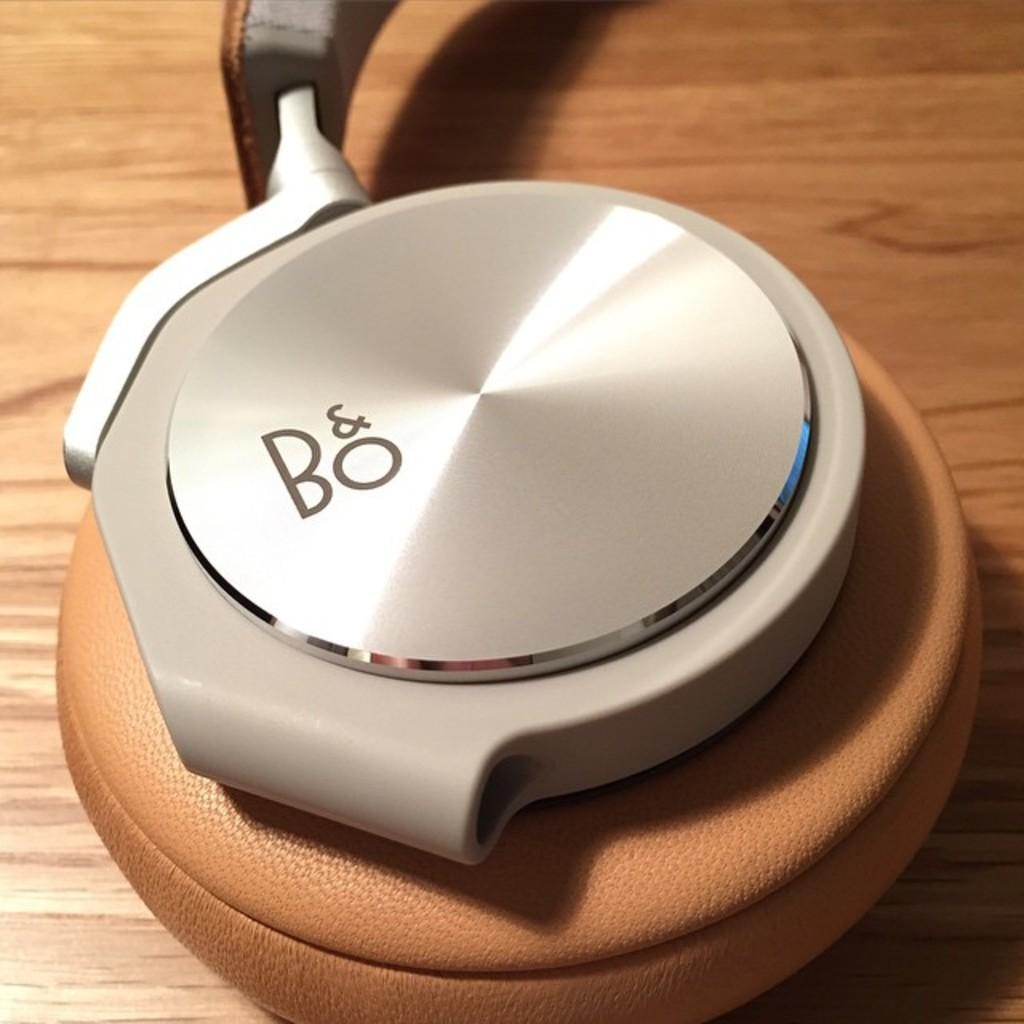What is the name on this?
Your answer should be compact. Bo. 